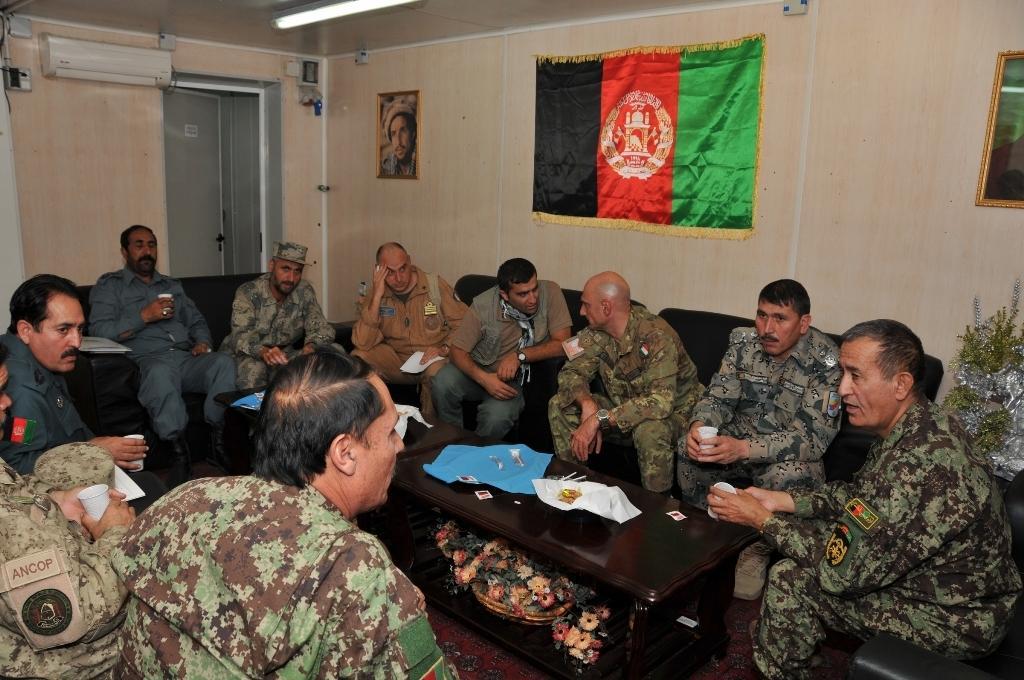Please provide a concise description of this image. There are few people sitting on the chair at the table and holding glass in their hands. On the table we can see cloth. In the background there is a wall,AC,banner,light and a door. 